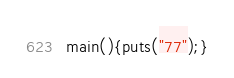<code> <loc_0><loc_0><loc_500><loc_500><_C_>main(){puts("77");}</code> 